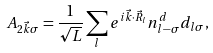<formula> <loc_0><loc_0><loc_500><loc_500>A _ { 2 \vec { k } \sigma } = \frac { 1 } { \sqrt { L } } \sum _ { l } e ^ { i \vec { k } \cdot \vec { R } _ { l } } n _ { l - \sigma } ^ { d } d _ { l \sigma } ,</formula> 